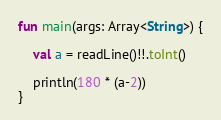<code> <loc_0><loc_0><loc_500><loc_500><_Kotlin_>fun main(args: Array<String>) {

    val a = readLine()!!.toInt()

    println(180 * (a-2))
}</code> 